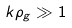Convert formula to latex. <formula><loc_0><loc_0><loc_500><loc_500>k \rho _ { g } \gg 1</formula> 